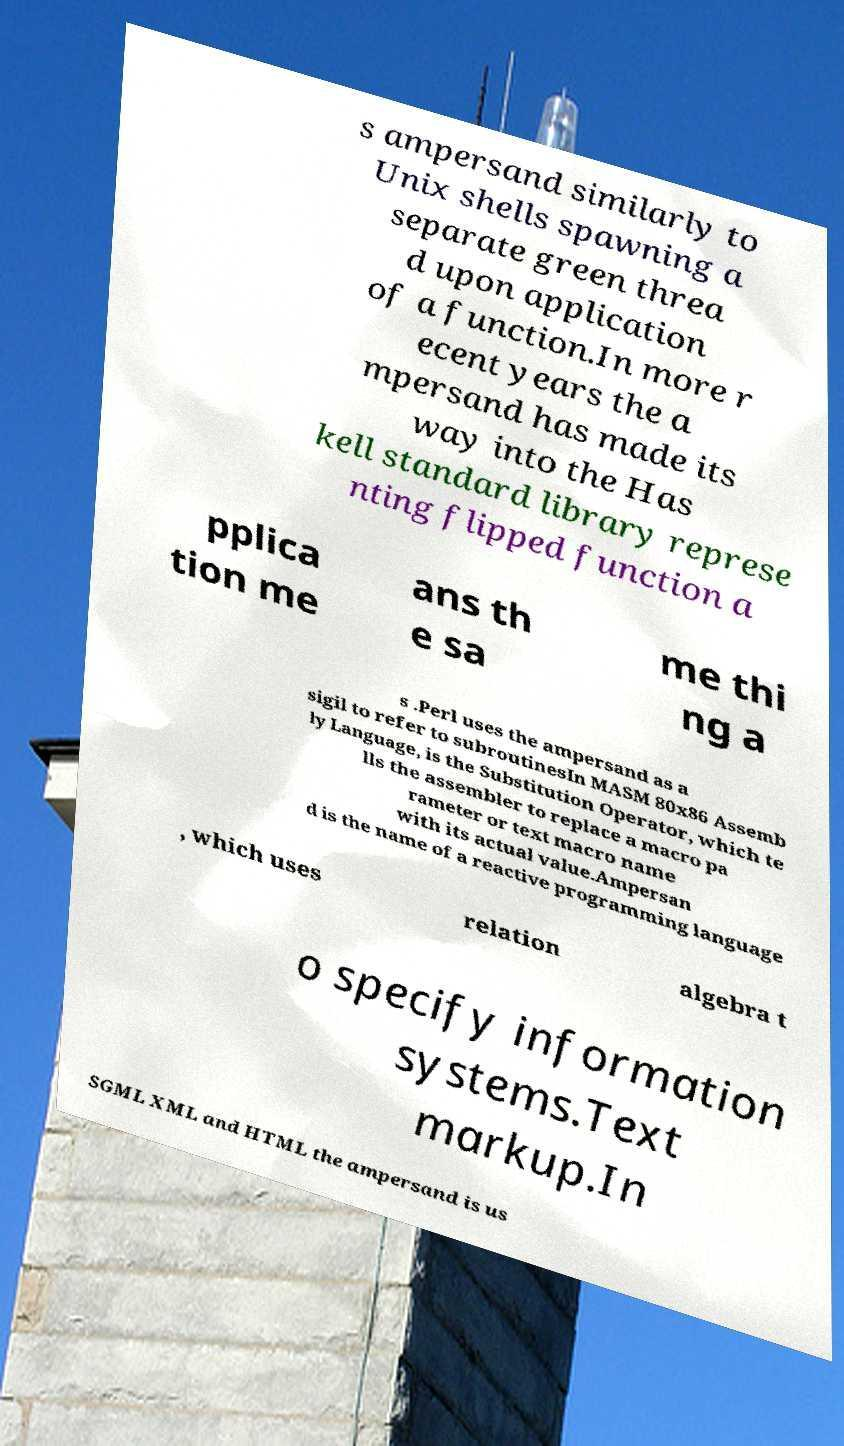Please read and relay the text visible in this image. What does it say? s ampersand similarly to Unix shells spawning a separate green threa d upon application of a function.In more r ecent years the a mpersand has made its way into the Has kell standard library represe nting flipped function a pplica tion me ans th e sa me thi ng a s .Perl uses the ampersand as a sigil to refer to subroutinesIn MASM 80x86 Assemb ly Language, is the Substitution Operator, which te lls the assembler to replace a macro pa rameter or text macro name with its actual value.Ampersan d is the name of a reactive programming language , which uses relation algebra t o specify information systems.Text markup.In SGML XML and HTML the ampersand is us 